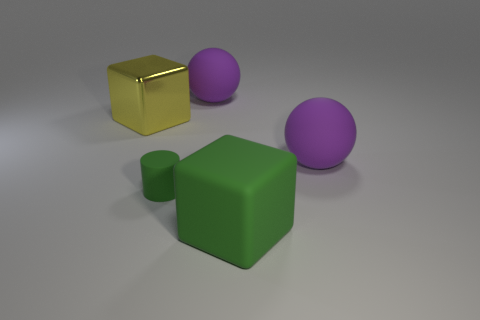Are there an equal number of yellow cubes that are to the left of the large metallic block and green things that are to the right of the green cube?
Your response must be concise. Yes. What size is the other green thing that is the same shape as the big metallic thing?
Give a very brief answer. Large. There is a rubber object that is both in front of the yellow metal object and behind the tiny green rubber cylinder; what size is it?
Your response must be concise. Large. There is a tiny green matte object; are there any small green rubber cylinders on the left side of it?
Provide a succinct answer. No. How many things are green things to the right of the tiny green rubber cylinder or tiny green cubes?
Your answer should be very brief. 1. There is a rubber sphere in front of the yellow cube; what number of spheres are on the right side of it?
Make the answer very short. 0. Is the number of big metal objects on the left side of the yellow shiny thing less than the number of green matte cylinders that are in front of the tiny rubber object?
Your response must be concise. No. The purple object that is right of the large block on the right side of the yellow thing is what shape?
Offer a terse response. Sphere. What number of other objects are there of the same material as the tiny green thing?
Give a very brief answer. 3. Are there any other things that are the same size as the yellow object?
Ensure brevity in your answer.  Yes. 